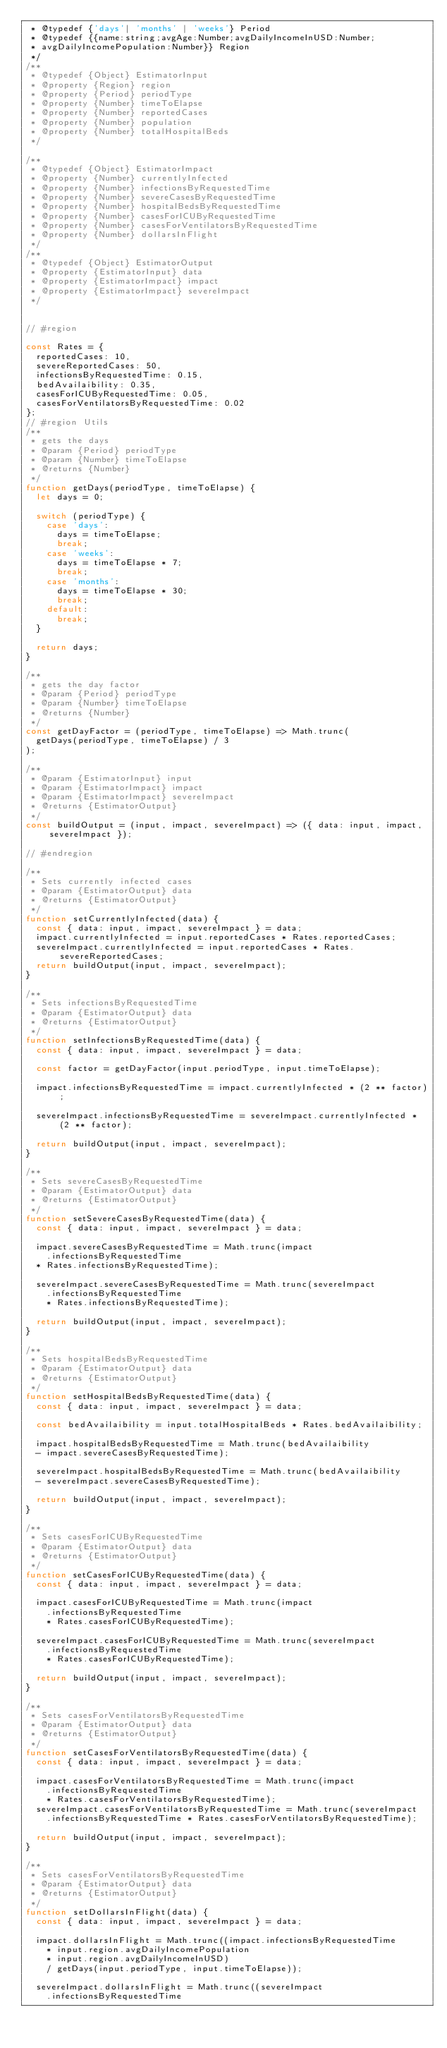Convert code to text. <code><loc_0><loc_0><loc_500><loc_500><_JavaScript_> * @typedef {'days'| 'months' | 'weeks'} Period
 * @typedef {{name:string;avgAge:Number;avgDailyIncomeInUSD:Number;
 * avgDailyIncomePopulation:Number}} Region
 */
/**
 * @typedef {Object} EstimatorInput
 * @property {Region} region
 * @property {Period} periodType
 * @property {Number} timeToElapse
 * @property {Number} reportedCases
 * @property {Number} population
 * @property {Number} totalHospitalBeds
 */

/**
 * @typedef {Object} EstimatorImpact
 * @property {Number} currentlyInfected
 * @property {Number} infectionsByRequestedTime
 * @property {Number} severeCasesByRequestedTime
 * @property {Number} hospitalBedsByRequestedTime
 * @property {Number} casesForICUByRequestedTime
 * @property {Number} casesForVentilatorsByRequestedTime
 * @property {Number} dollarsInFlight
 */
/**
 * @typedef {Object} EstimatorOutput
 * @property {EstimatorInput} data
 * @property {EstimatorImpact} impact
 * @property {EstimatorImpact} severeImpact
 */


// #region

const Rates = {
  reportedCases: 10,
  severeReportedCases: 50,
  infectionsByRequestedTime: 0.15,
  bedAvailaibility: 0.35,
  casesForICUByRequestedTime: 0.05,
  casesForVentilatorsByRequestedTime: 0.02
};
// #region Utils
/**
 * gets the days
 * @param {Period} periodType
 * @param {Number} timeToElapse
 * @returns {Number}
 */
function getDays(periodType, timeToElapse) {
  let days = 0;

  switch (periodType) {
    case 'days':
      days = timeToElapse;
      break;
    case 'weeks':
      days = timeToElapse * 7;
      break;
    case 'months':
      days = timeToElapse * 30;
      break;
    default:
      break;
  }

  return days;
}

/**
 * gets the day factor
 * @param {Period} periodType
 * @param {Number} timeToElapse
 * @returns {Number}
 */
const getDayFactor = (periodType, timeToElapse) => Math.trunc(
  getDays(periodType, timeToElapse) / 3
);

/**
 * @param {EstimatorInput} input
 * @param {EstimatorImpact} impact
 * @param {EstimatorImpact} severeImpact
 * @returns {EstimatorOutput}
 */
const buildOutput = (input, impact, severeImpact) => ({ data: input, impact, severeImpact });

// #endregion

/**
 * Sets currently infected cases
 * @param {EstimatorOutput} data
 * @returns {EstimatorOutput}
 */
function setCurrentlyInfected(data) {
  const { data: input, impact, severeImpact } = data;
  impact.currentlyInfected = input.reportedCases * Rates.reportedCases;
  severeImpact.currentlyInfected = input.reportedCases * Rates.severeReportedCases;
  return buildOutput(input, impact, severeImpact);
}

/**
 * Sets infectionsByRequestedTime
 * @param {EstimatorOutput} data
 * @returns {EstimatorOutput}
 */
function setInfectionsByRequestedTime(data) {
  const { data: input, impact, severeImpact } = data;

  const factor = getDayFactor(input.periodType, input.timeToElapse);

  impact.infectionsByRequestedTime = impact.currentlyInfected * (2 ** factor);

  severeImpact.infectionsByRequestedTime = severeImpact.currentlyInfected * (2 ** factor);

  return buildOutput(input, impact, severeImpact);
}

/**
 * Sets severeCasesByRequestedTime
 * @param {EstimatorOutput} data
 * @returns {EstimatorOutput}
 */
function setSevereCasesByRequestedTime(data) {
  const { data: input, impact, severeImpact } = data;

  impact.severeCasesByRequestedTime = Math.trunc(impact
    .infectionsByRequestedTime
  * Rates.infectionsByRequestedTime);

  severeImpact.severeCasesByRequestedTime = Math.trunc(severeImpact
    .infectionsByRequestedTime
    * Rates.infectionsByRequestedTime);

  return buildOutput(input, impact, severeImpact);
}

/**
 * Sets hospitalBedsByRequestedTime
 * @param {EstimatorOutput} data
 * @returns {EstimatorOutput}
 */
function setHospitalBedsByRequestedTime(data) {
  const { data: input, impact, severeImpact } = data;

  const bedAvailaibility = input.totalHospitalBeds * Rates.bedAvailaibility;

  impact.hospitalBedsByRequestedTime = Math.trunc(bedAvailaibility
  - impact.severeCasesByRequestedTime);

  severeImpact.hospitalBedsByRequestedTime = Math.trunc(bedAvailaibility
  - severeImpact.severeCasesByRequestedTime);

  return buildOutput(input, impact, severeImpact);
}

/**
 * Sets casesForICUByRequestedTime
 * @param {EstimatorOutput} data
 * @returns {EstimatorOutput}
 */
function setCasesForICUByRequestedTime(data) {
  const { data: input, impact, severeImpact } = data;

  impact.casesForICUByRequestedTime = Math.trunc(impact
    .infectionsByRequestedTime
    * Rates.casesForICUByRequestedTime);

  severeImpact.casesForICUByRequestedTime = Math.trunc(severeImpact
    .infectionsByRequestedTime
    * Rates.casesForICUByRequestedTime);

  return buildOutput(input, impact, severeImpact);
}

/**
 * Sets casesForVentilatorsByRequestedTime
 * @param {EstimatorOutput} data
 * @returns {EstimatorOutput}
 */
function setCasesForVentilatorsByRequestedTime(data) {
  const { data: input, impact, severeImpact } = data;

  impact.casesForVentilatorsByRequestedTime = Math.trunc(impact
    .infectionsByRequestedTime
    * Rates.casesForVentilatorsByRequestedTime);
  severeImpact.casesForVentilatorsByRequestedTime = Math.trunc(severeImpact
    .infectionsByRequestedTime * Rates.casesForVentilatorsByRequestedTime);

  return buildOutput(input, impact, severeImpact);
}

/**
 * Sets casesForVentilatorsByRequestedTime
 * @param {EstimatorOutput} data
 * @returns {EstimatorOutput}
 */
function setDollarsInFlight(data) {
  const { data: input, impact, severeImpact } = data;

  impact.dollarsInFlight = Math.trunc((impact.infectionsByRequestedTime
    * input.region.avgDailyIncomePopulation
    * input.region.avgDailyIncomeInUSD)
    / getDays(input.periodType, input.timeToElapse));

  severeImpact.dollarsInFlight = Math.trunc((severeImpact
    .infectionsByRequestedTime</code> 